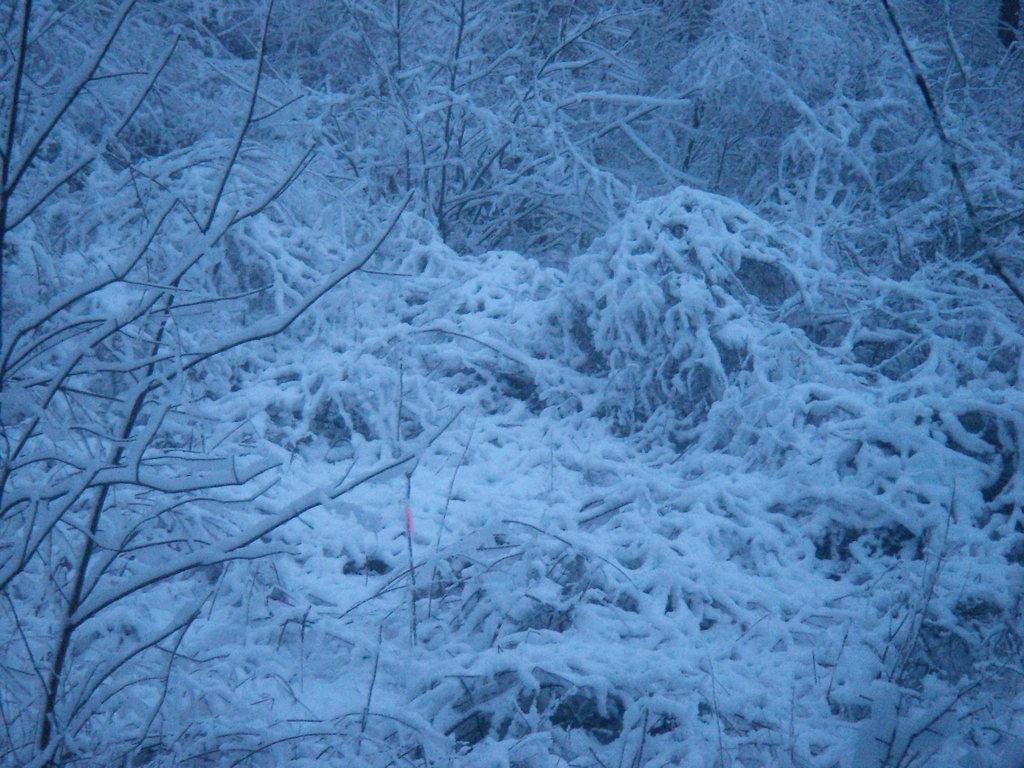Can you describe this image briefly? In this image we can see trees covered by snow. 